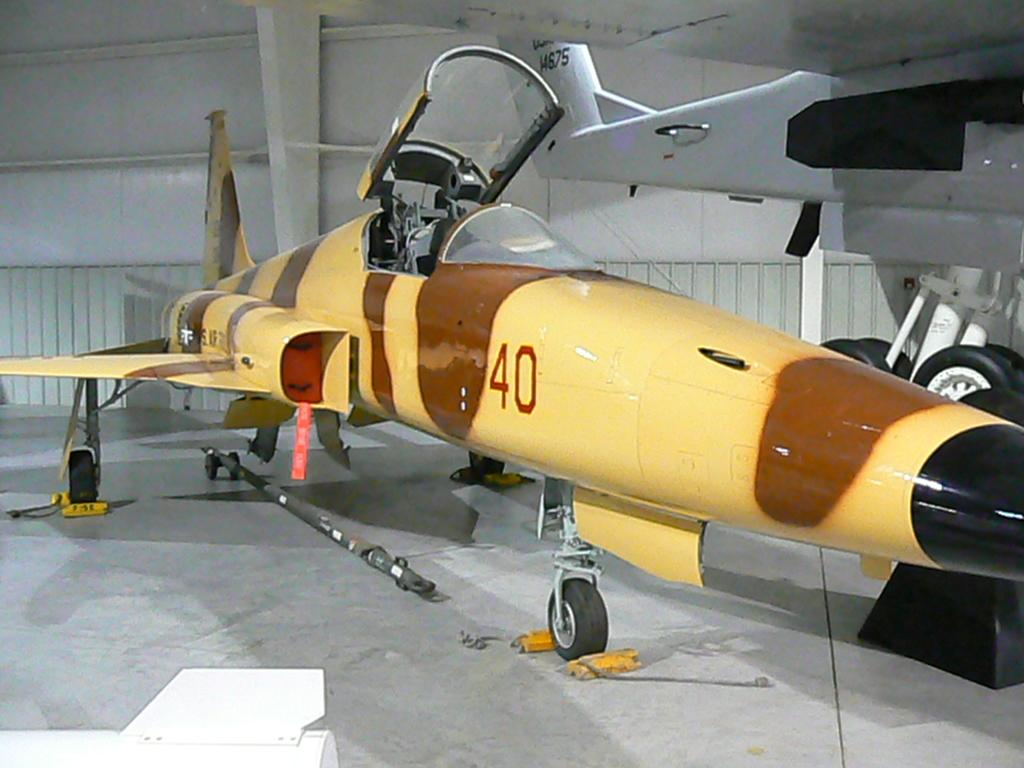<image>
Create a compact narrative representing the image presented. A yellow and brown plane has the number 40 painted on the side of it. 